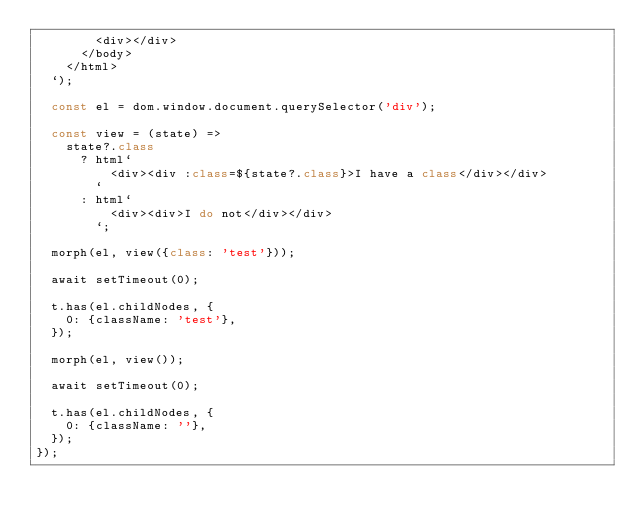<code> <loc_0><loc_0><loc_500><loc_500><_JavaScript_>        <div></div>
      </body>
    </html>
  `);

  const el = dom.window.document.querySelector('div');

  const view = (state) =>
    state?.class
      ? html`
          <div><div :class=${state?.class}>I have a class</div></div>
        `
      : html`
          <div><div>I do not</div></div>
        `;

  morph(el, view({class: 'test'}));

  await setTimeout(0);

  t.has(el.childNodes, {
    0: {className: 'test'},
  });

  morph(el, view());

  await setTimeout(0);

  t.has(el.childNodes, {
    0: {className: ''},
  });
});
</code> 